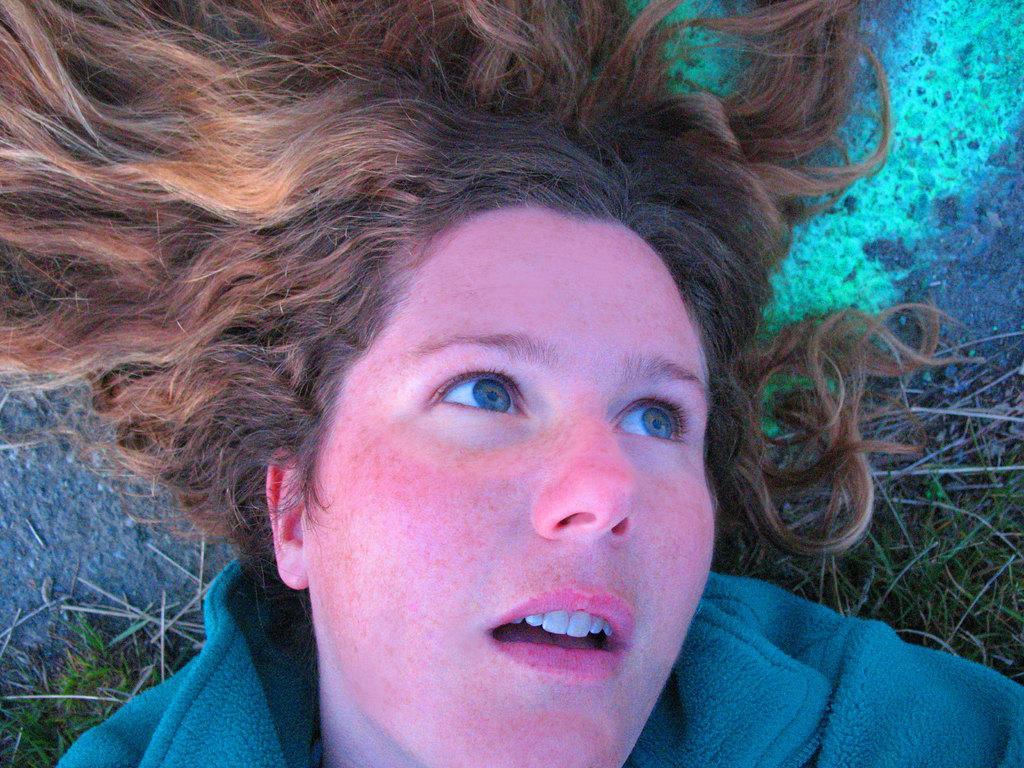Describe this image in one or two sentences. This image is taken outdoors. At the bottom of the image a woman is lying on the ground. In the background there is a ground with grass on it. 